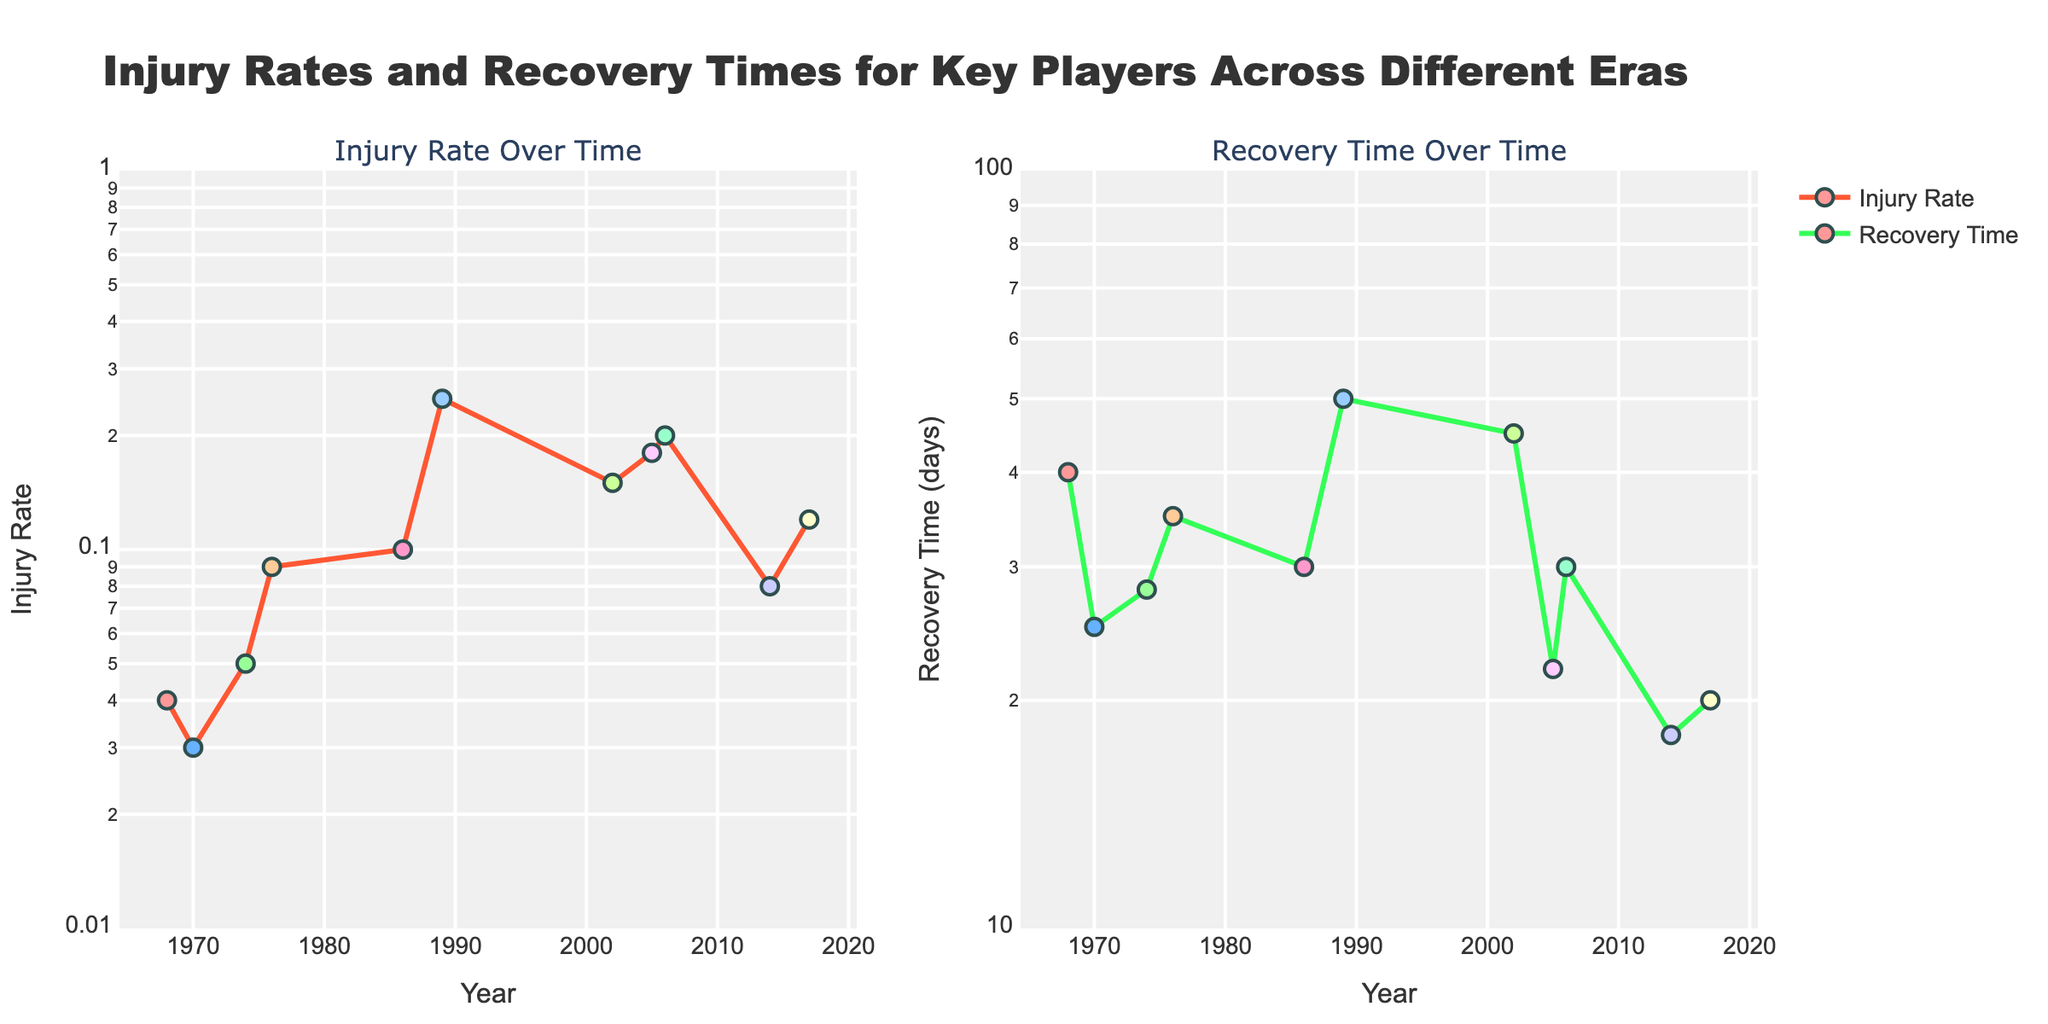What is the title of the figure? The title of the figure is displayed at the top center of the plot. It reads "Injury Rates and Recovery Times for Key Players Across Different Eras".
Answer: Injury Rates and Recovery Times for Key Players Across Different Eras What are the x-axes representing in both subplots? In both subplots (Injury Rate Over Time and Recovery Time Over Time), the x-axis represents the "Year" when the players' data was recorded.
Answer: Year Which player has the highest injury rate recorded? The highest injury rate is indicated by the peak point on the Injury Rate subplot. The peak value is 0.25, which corresponds to Marco van Basten in 1989.
Answer: Marco van Basten Which player has the lowest recovery time, and what is it? The lowest recovery time is indicated by the lowest point on the Recovery Time subplot. The value is 18 days, corresponding to Lionel Messi in 2014.
Answer: Lionel Messi, 18 days Compare Diego Maradona's injury rate and recovery time to David Beckham's. Diego Maradona has an injury rate of 0.1 and a recovery time of 30 days, whereas David Beckham has a higher injury rate of 0.2 and the same recovery time of 30 days. This shows Beckham’s injury rate is twice that of Maradona's, but their recovery periods are equal.
Answer: Maradona: 0.1, 30 days; Beckham: 0.2, 30 days Who has a shorter recovery time, Ronaldinho or Johan Cruyff, and by how many days? Ronaldinho's recovery time is 22 days, whereas Johan Cruyff's recovery time is 28 days. The difference between their recovery times is 28 - 22 = 6 days.
Answer: Ronaldinho by 6 days Are there any players with an injury rate lower than 0.05? If so, who are they? By examining the Injury Rate subplot, players with injury rates below 0.05 are Pele (0.03) and George Best (0.04).
Answer: Pele, George Best Which era (represented by decades) exhibits the highest overall recovery times? Observing the Recovery Time subplot, the 1980s, particularly through Marco van Basten's and Diego Maradona's recovery times, shows significant peaks. This indicates the 1980s have the highest overall recovery times.
Answer: 1980s What is the average injury rate for players from the 2000s? The players from the 2000s are Zinedine Zidane, David Beckham, and Ronaldinho with injury rates of 0.15, 0.2, and 0.18 respectively. The average is (0.15 + 0.2 + 0.18) / 3 = 0.18.
Answer: 0.18 